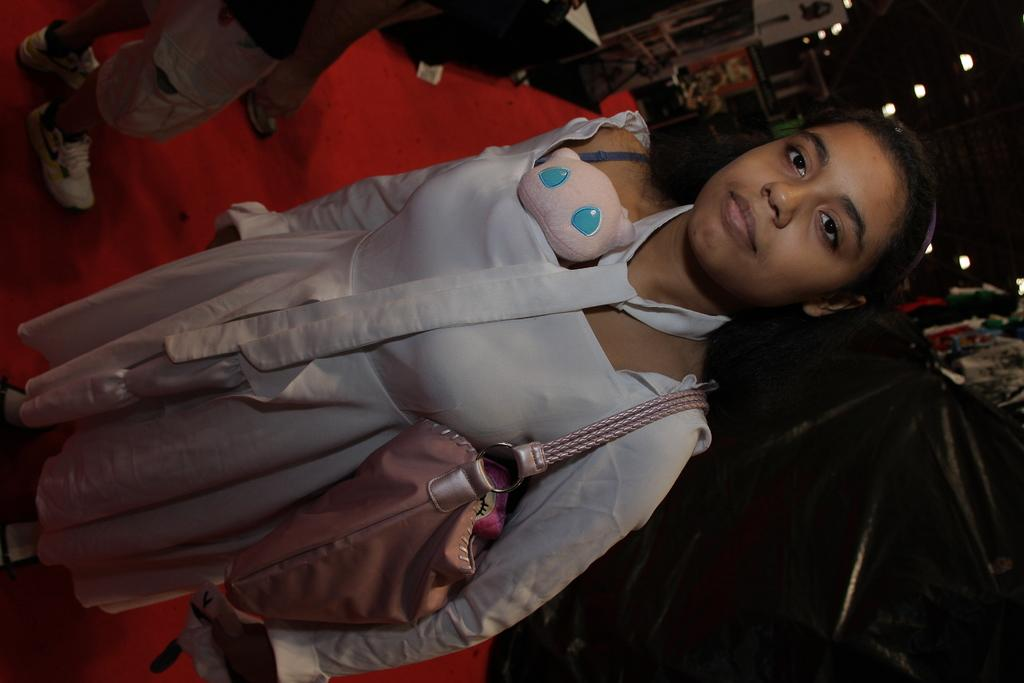What is the main subject of the image? There is a woman in the image. What is the woman doing in the image? The woman is standing in the image. What is the woman holding or carrying in the image? The woman is carrying a bag in the image. What can be seen in the background of the image? There are lights, people, and other objects on the ground in the background of the image. What type of discussion is taking place between the birds in the image? There are no birds present in the image, so no discussion can be observed. What is the woman using to catch the fish in the image? There is no fishing activity or net present in the image; the woman is simply carrying a bag. 